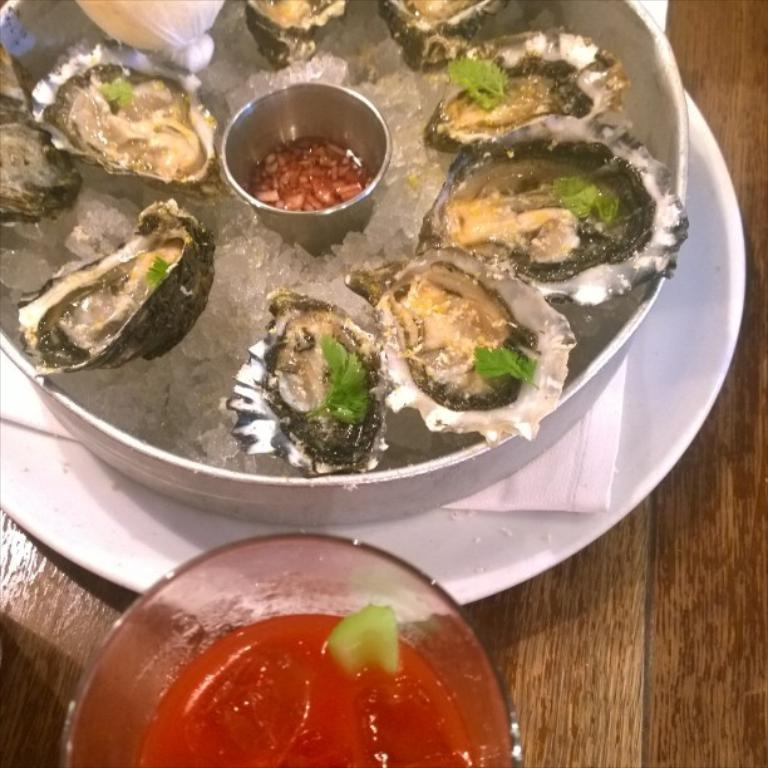What is in the bowl that is visible in the image? There is a food item in a bowl in the image. How is the bowl positioned on the plate? The bowl is placed on a plate in the image. Where is the plate located? The plate is on a table in the image. Can you describe another bowl in the image? Yes, there is a glass bowl with some sauce in the image. What type of spot can be seen on the coat of the person in the image? There is no person or coat present in the image. 